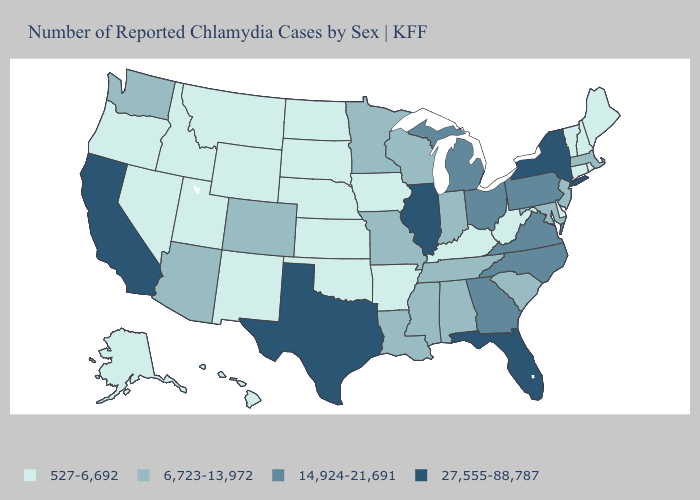Among the states that border New Mexico , which have the highest value?
Give a very brief answer. Texas. Name the states that have a value in the range 6,723-13,972?
Give a very brief answer. Alabama, Arizona, Colorado, Indiana, Louisiana, Maryland, Massachusetts, Minnesota, Mississippi, Missouri, New Jersey, South Carolina, Tennessee, Washington, Wisconsin. Among the states that border Arkansas , which have the lowest value?
Concise answer only. Oklahoma. What is the value of Ohio?
Quick response, please. 14,924-21,691. Name the states that have a value in the range 27,555-88,787?
Answer briefly. California, Florida, Illinois, New York, Texas. What is the lowest value in the West?
Concise answer only. 527-6,692. Does the first symbol in the legend represent the smallest category?
Write a very short answer. Yes. Name the states that have a value in the range 14,924-21,691?
Be succinct. Georgia, Michigan, North Carolina, Ohio, Pennsylvania, Virginia. Name the states that have a value in the range 527-6,692?
Short answer required. Alaska, Arkansas, Connecticut, Delaware, Hawaii, Idaho, Iowa, Kansas, Kentucky, Maine, Montana, Nebraska, Nevada, New Hampshire, New Mexico, North Dakota, Oklahoma, Oregon, Rhode Island, South Dakota, Utah, Vermont, West Virginia, Wyoming. Name the states that have a value in the range 6,723-13,972?
Short answer required. Alabama, Arizona, Colorado, Indiana, Louisiana, Maryland, Massachusetts, Minnesota, Mississippi, Missouri, New Jersey, South Carolina, Tennessee, Washington, Wisconsin. What is the lowest value in the USA?
Write a very short answer. 527-6,692. What is the value of Oregon?
Write a very short answer. 527-6,692. Which states have the lowest value in the South?
Short answer required. Arkansas, Delaware, Kentucky, Oklahoma, West Virginia. What is the value of Iowa?
Concise answer only. 527-6,692. Does New York have the highest value in the USA?
Quick response, please. Yes. 